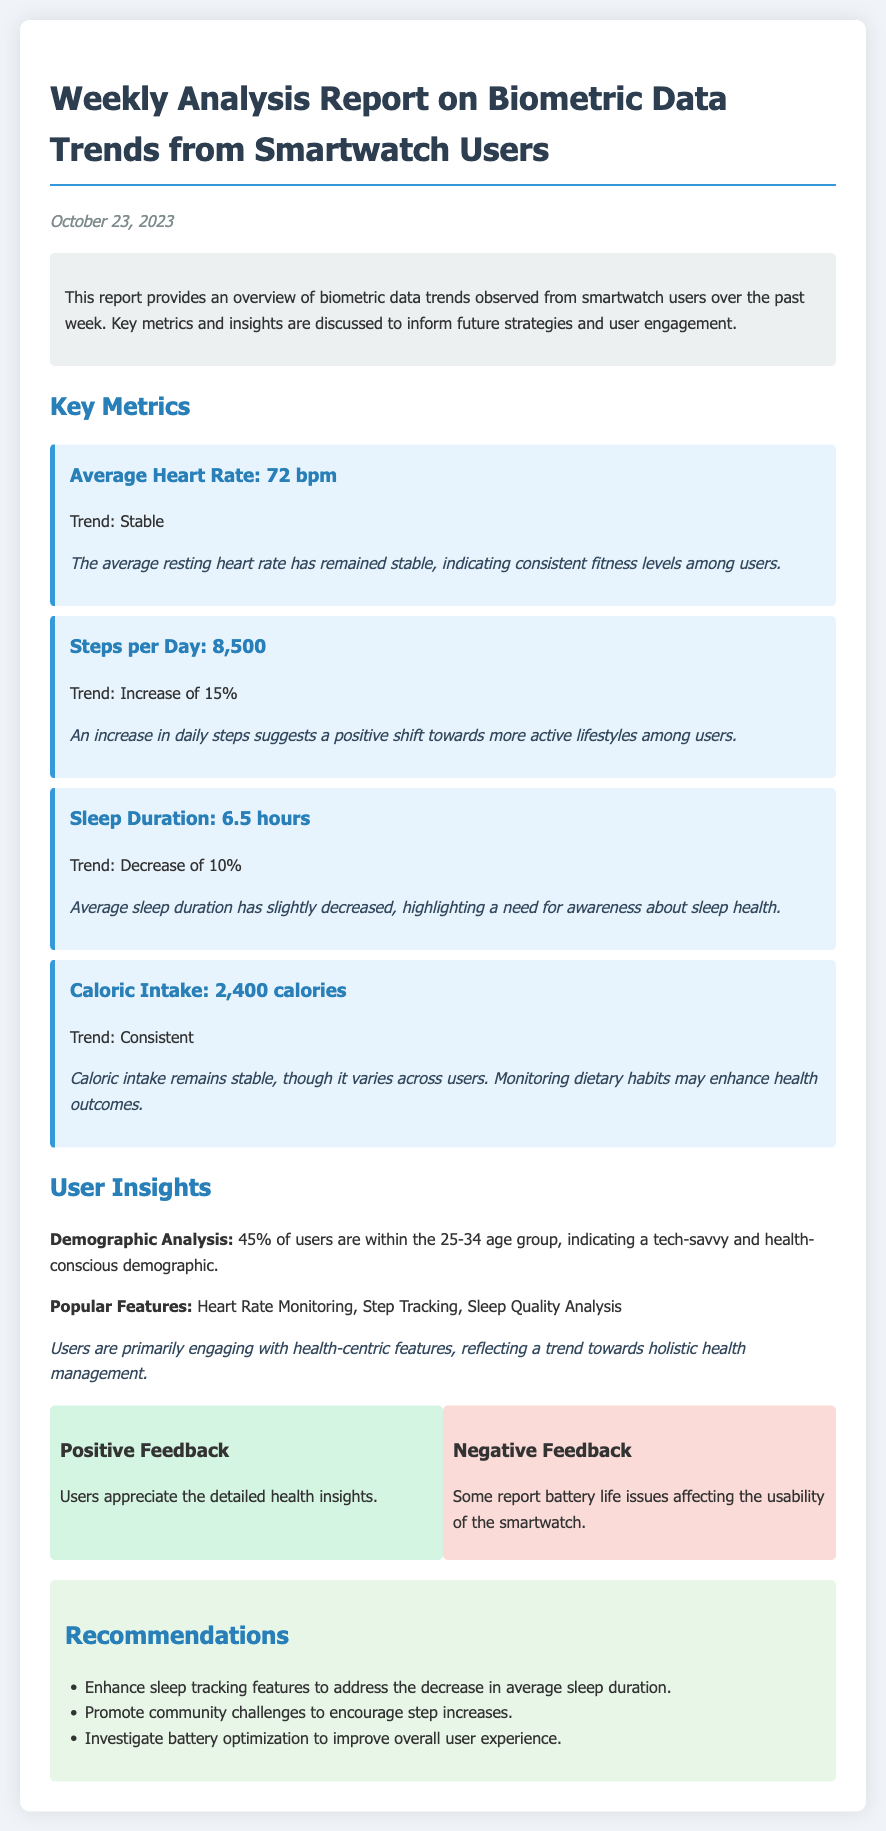What is the average heart rate reported? The average heart rate is explicitly mentioned in the document as 72 bpm.
Answer: 72 bpm What was the increase in steps per day reported? The document states there was an increase of 15% in steps per day.
Answer: 15% What is the average sleep duration? The average sleep duration noted in the report is 6.5 hours.
Answer: 6.5 hours What percentage of users are within the 25-34 age group? The document indicates that 45% of users fall into this age group.
Answer: 45% What key recommendation is made regarding sleep tracking? The recommendations include enhancing sleep tracking features to address the decrease in average sleep duration.
Answer: Enhance sleep tracking features What are the most engaging user features? The report highlights that heart rate monitoring, step tracking, and sleep quality analysis are popular features.
Answer: Heart Rate Monitoring, Step Tracking, Sleep Quality Analysis What trend does the average caloric intake show? The report indicates that caloric intake remains stable, with no significant changes.
Answer: Consistent What type of feedback do users provide about health insights? Users appreciate detailed health insights according to the positive feedback section.
Answer: Detailed health insights What battery-related issue do users report? Some users report battery life issues that affect smartwatch usability.
Answer: Battery life issues 